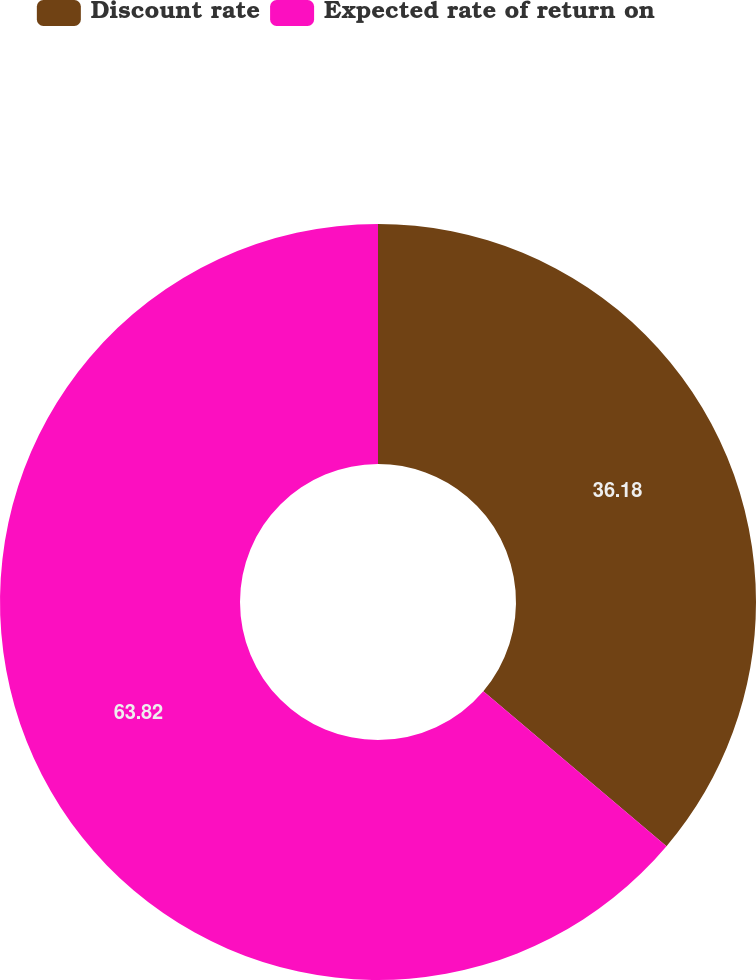<chart> <loc_0><loc_0><loc_500><loc_500><pie_chart><fcel>Discount rate<fcel>Expected rate of return on<nl><fcel>36.18%<fcel>63.82%<nl></chart> 